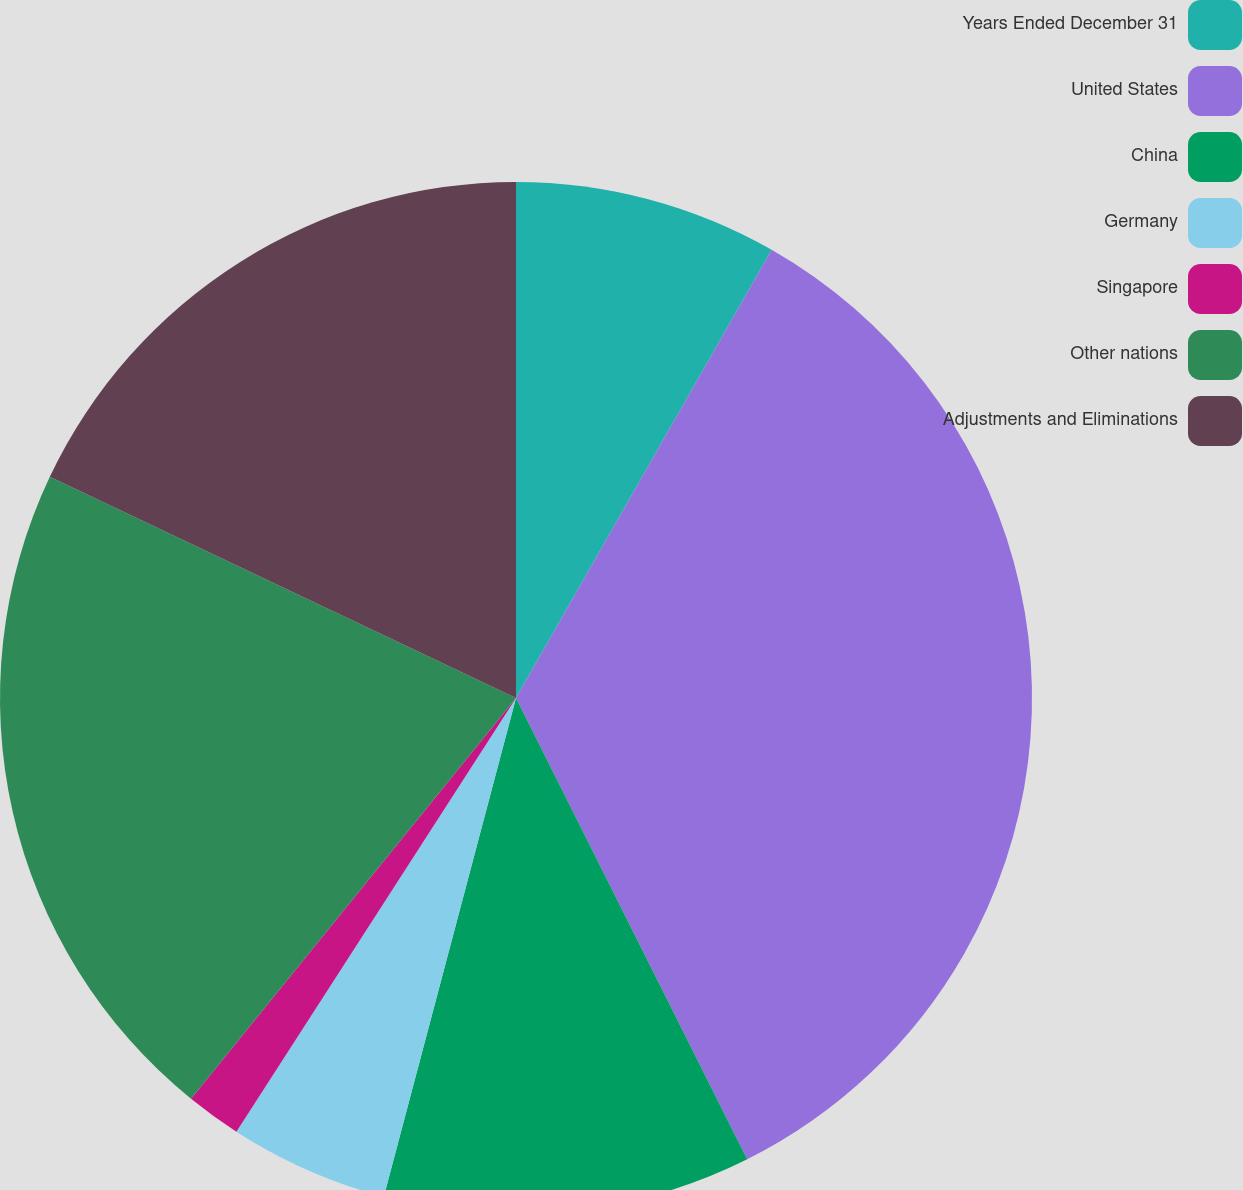<chart> <loc_0><loc_0><loc_500><loc_500><pie_chart><fcel>Years Ended December 31<fcel>United States<fcel>China<fcel>Germany<fcel>Singapore<fcel>Other nations<fcel>Adjustments and Eliminations<nl><fcel>8.25%<fcel>34.36%<fcel>11.52%<fcel>4.99%<fcel>1.73%<fcel>21.21%<fcel>17.95%<nl></chart> 